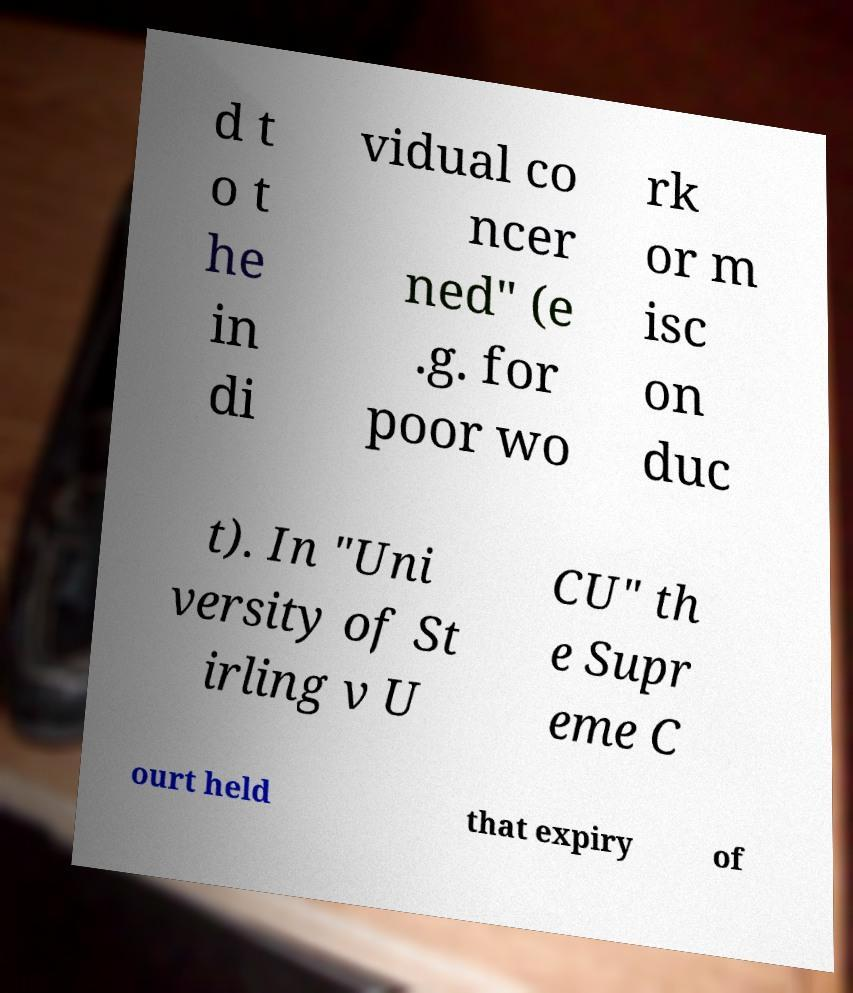For documentation purposes, I need the text within this image transcribed. Could you provide that? d t o t he in di vidual co ncer ned" (e .g. for poor wo rk or m isc on duc t). In "Uni versity of St irling v U CU" th e Supr eme C ourt held that expiry of 